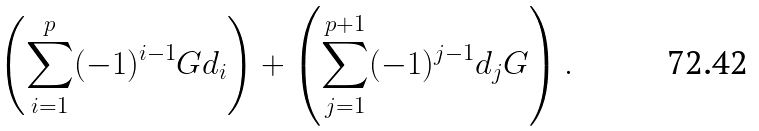<formula> <loc_0><loc_0><loc_500><loc_500>\left ( \sum _ { i = 1 } ^ { p } ( - 1 ) ^ { i - 1 } G d _ { i } \right ) + \left ( \sum _ { j = 1 } ^ { p + 1 } ( - 1 ) ^ { j - 1 } d _ { j } G \right ) .</formula> 